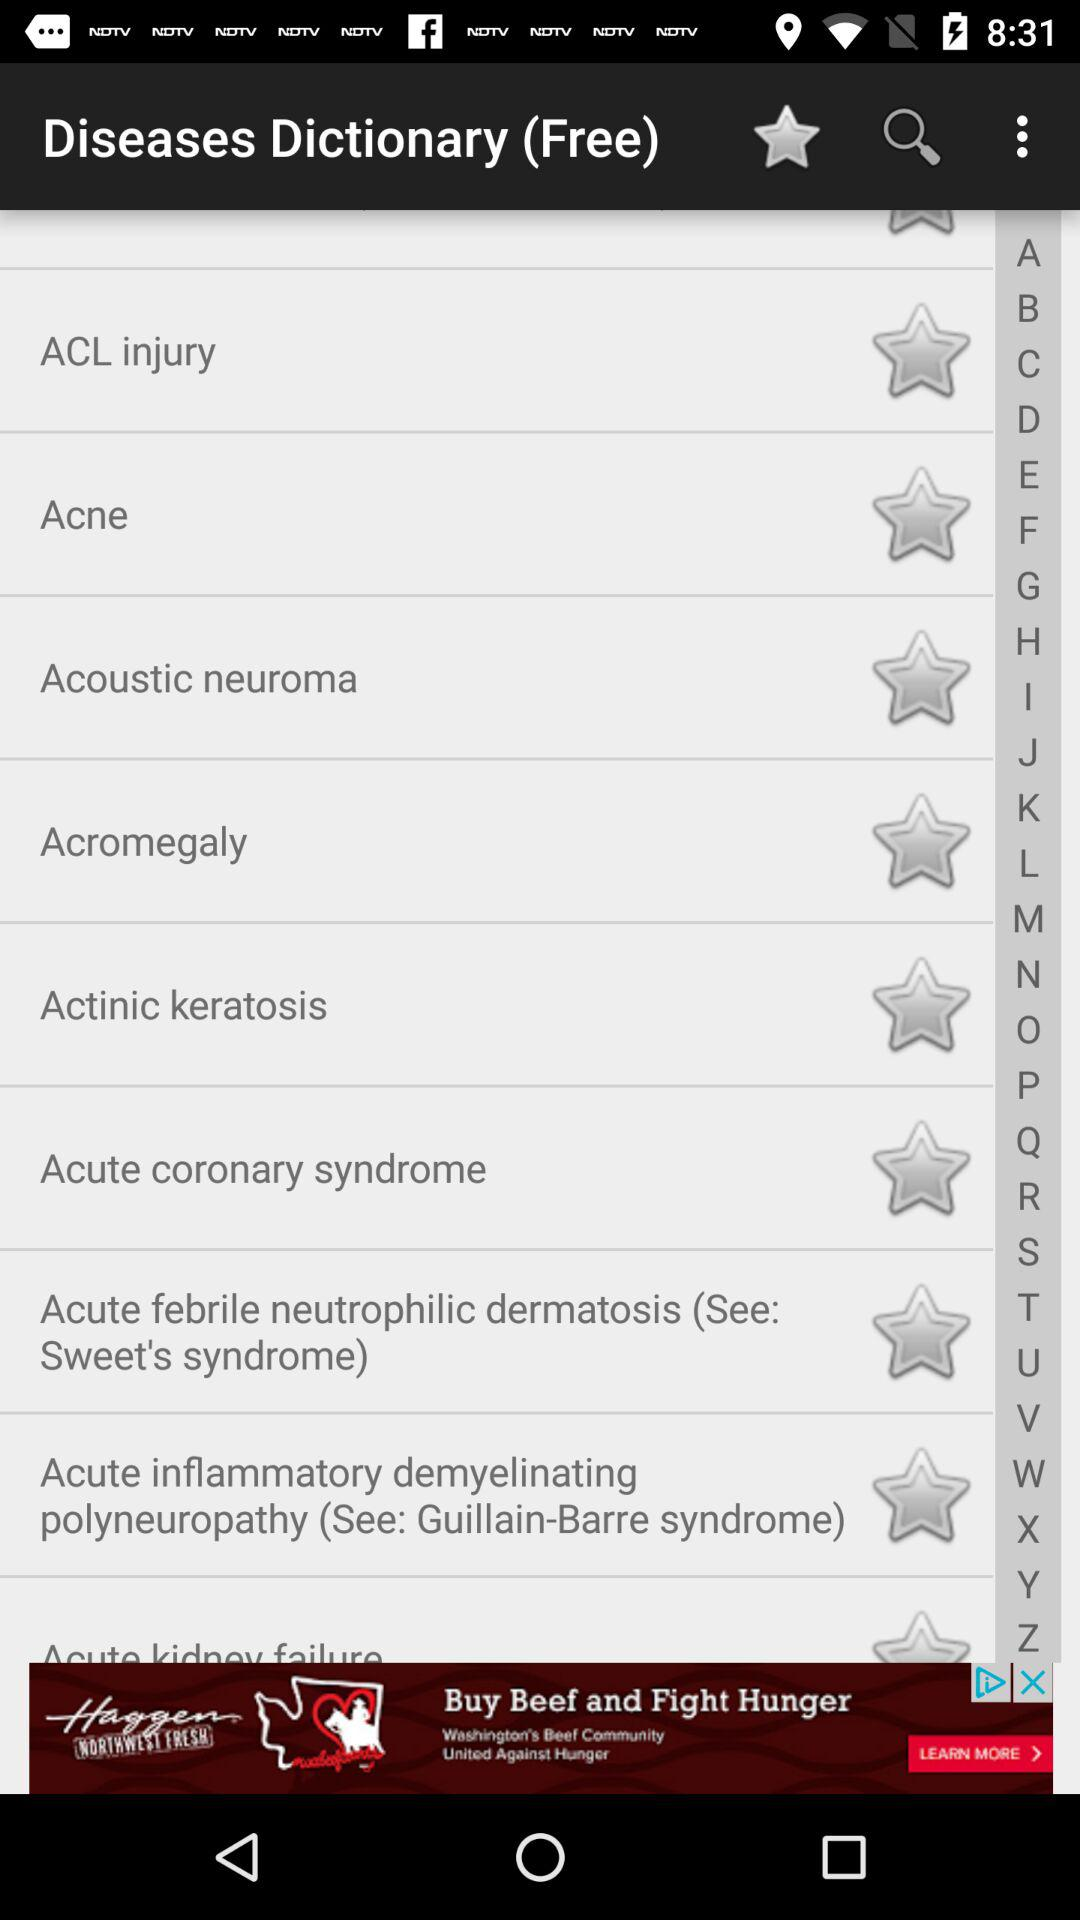What is the name of the application? The name of the application is "Diseases Dictionary (Free)". 